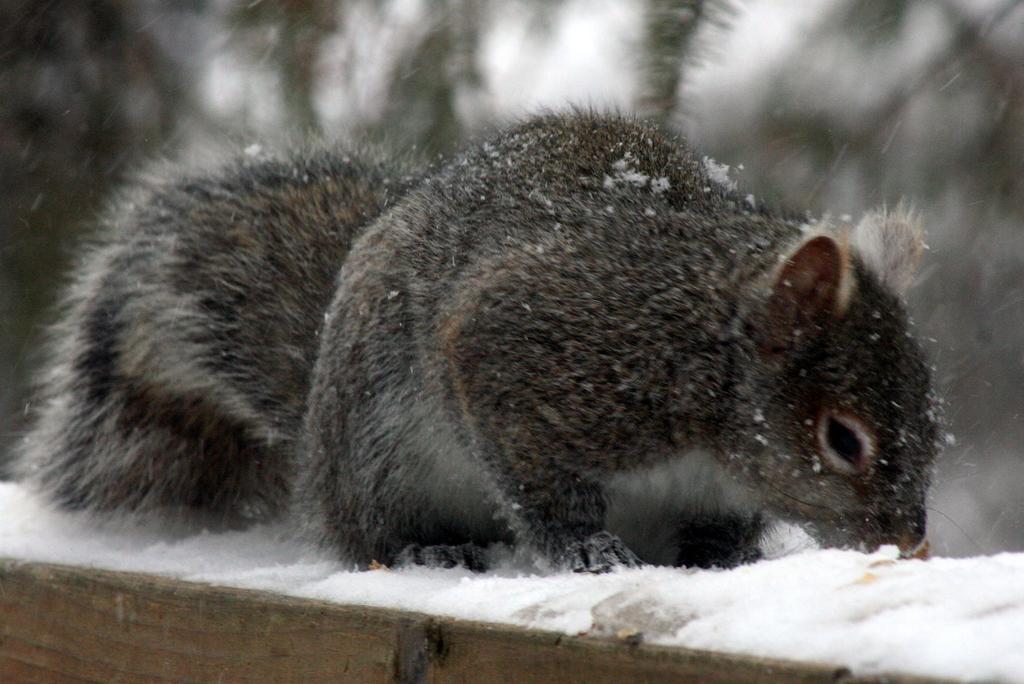In one or two sentences, can you explain what this image depicts? In this picture we can see black squirrel who is standing on the snow. In the background we can see the trees and sky. At the bottom there is a wooden bench. 